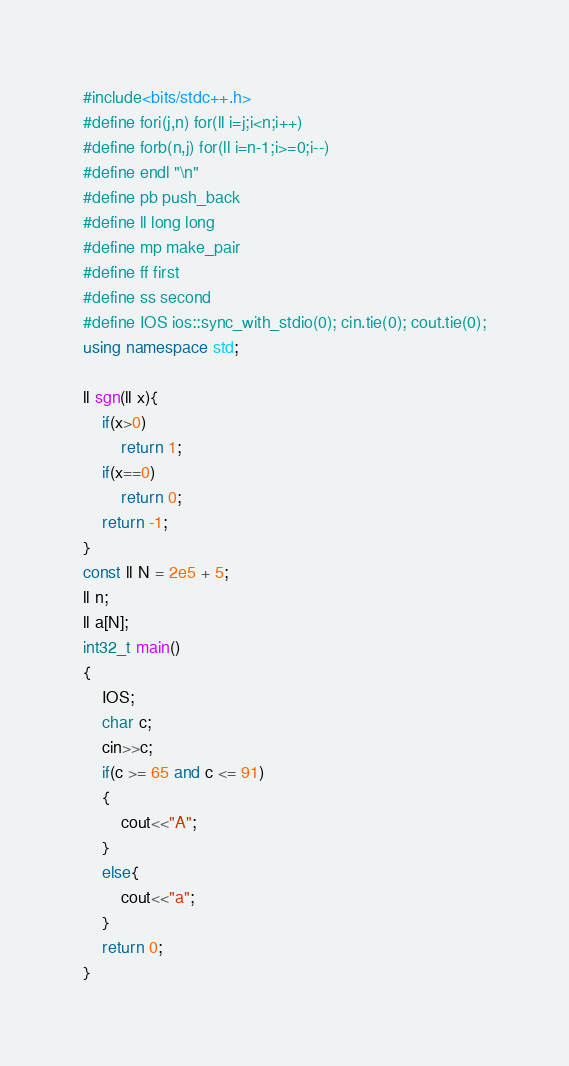Convert code to text. <code><loc_0><loc_0><loc_500><loc_500><_C++_>#include<bits/stdc++.h>
#define fori(j,n) for(ll i=j;i<n;i++)
#define forb(n,j) for(ll i=n-1;i>=0;i--)
#define endl "\n"
#define pb push_back
#define ll long long
#define mp make_pair
#define ff first
#define ss second
#define IOS ios::sync_with_stdio(0); cin.tie(0); cout.tie(0);
using namespace std;

ll sgn(ll x){
    if(x>0)
        return 1;
    if(x==0)
        return 0;
    return -1;
}
const ll N = 2e5 + 5;
ll n;
ll a[N];
int32_t main()
{
    IOS;
    char c;
    cin>>c;
    if(c >= 65 and c <= 91)
    {
        cout<<"A";
    }
    else{
        cout<<"a";
    }
    return 0;
}


</code> 